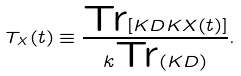<formula> <loc_0><loc_0><loc_500><loc_500>T _ { X } ( t ) \equiv \frac { \text {Tr} [ K D K X ( t ) ] } { k \text {Tr} ( K D ) } .</formula> 